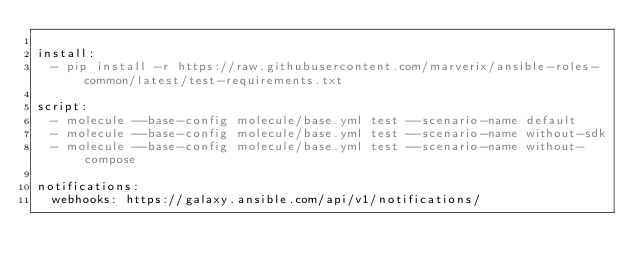Convert code to text. <code><loc_0><loc_0><loc_500><loc_500><_YAML_>
install:
  - pip install -r https://raw.githubusercontent.com/marverix/ansible-roles-common/latest/test-requirements.txt

script:
  - molecule --base-config molecule/base.yml test --scenario-name default
  - molecule --base-config molecule/base.yml test --scenario-name without-sdk
  - molecule --base-config molecule/base.yml test --scenario-name without-compose

notifications:
  webhooks: https://galaxy.ansible.com/api/v1/notifications/
</code> 